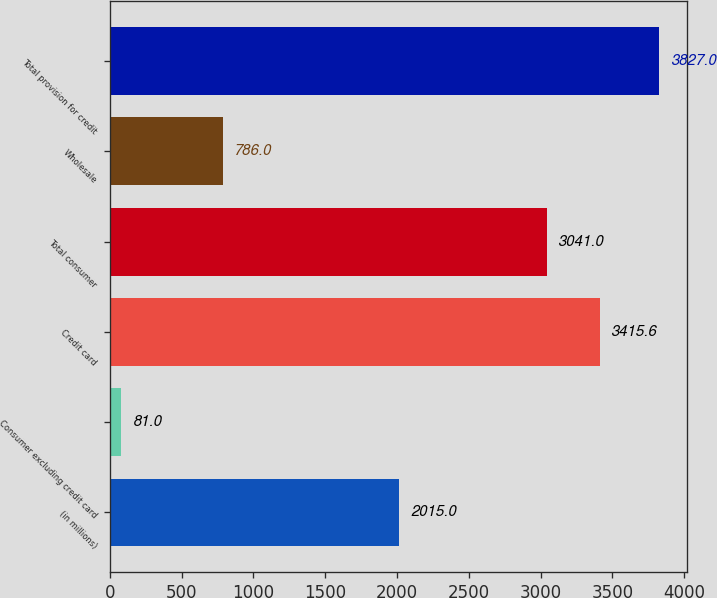<chart> <loc_0><loc_0><loc_500><loc_500><bar_chart><fcel>(in millions)<fcel>Consumer excluding credit card<fcel>Credit card<fcel>Total consumer<fcel>Wholesale<fcel>Total provision for credit<nl><fcel>2015<fcel>81<fcel>3415.6<fcel>3041<fcel>786<fcel>3827<nl></chart> 